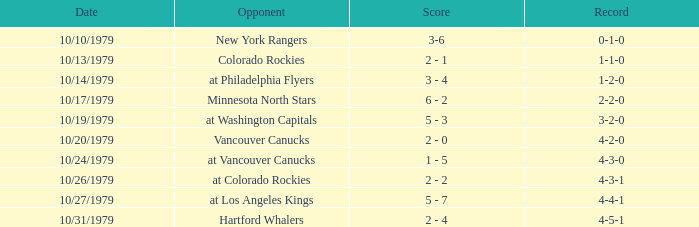What is the score for the opponent Vancouver Canucks? 2 - 0. 